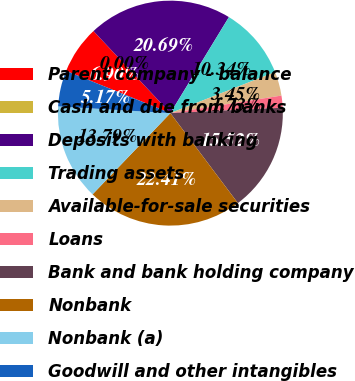<chart> <loc_0><loc_0><loc_500><loc_500><pie_chart><fcel>Parent company - balance<fcel>Cash and due from banks<fcel>Deposits with banking<fcel>Trading assets<fcel>Available-for-sale securities<fcel>Loans<fcel>Bank and bank holding company<fcel>Nonbank<fcel>Nonbank (a)<fcel>Goodwill and other intangibles<nl><fcel>6.9%<fcel>0.0%<fcel>20.69%<fcel>10.34%<fcel>3.45%<fcel>1.73%<fcel>15.52%<fcel>22.41%<fcel>13.79%<fcel>5.17%<nl></chart> 